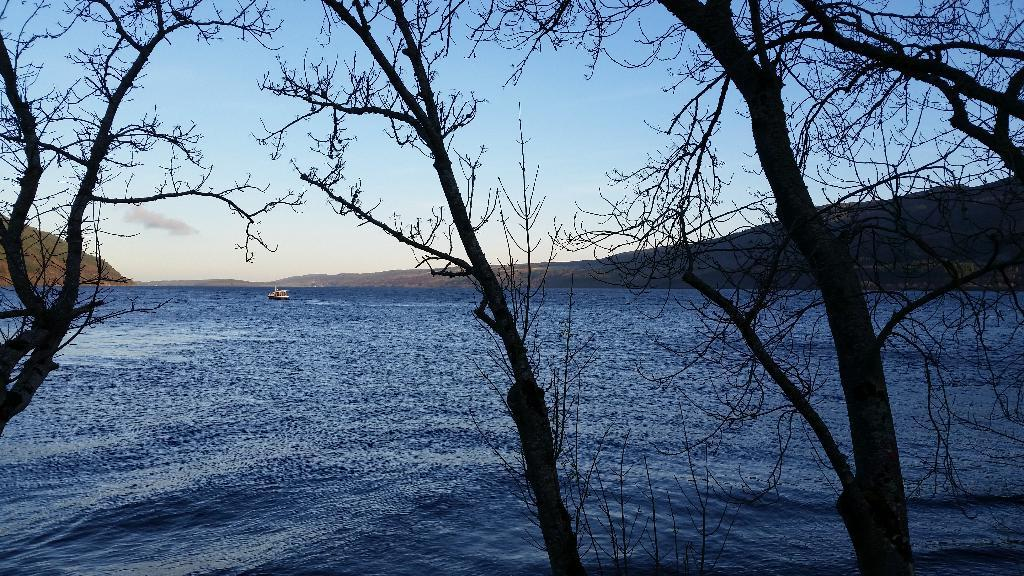What is at the bottom of the image? There is water at the bottom of the image. What is floating on the water? There is a boat in the water. What type of vegetation can be seen in the image? There are trees visible in the image. What is visible at the top of the image? The sky is visible at the top of the image. Where is the bulb located in the image? There is no bulb present in the image. What are the hands doing in the image? There are no hands visible in the image. 